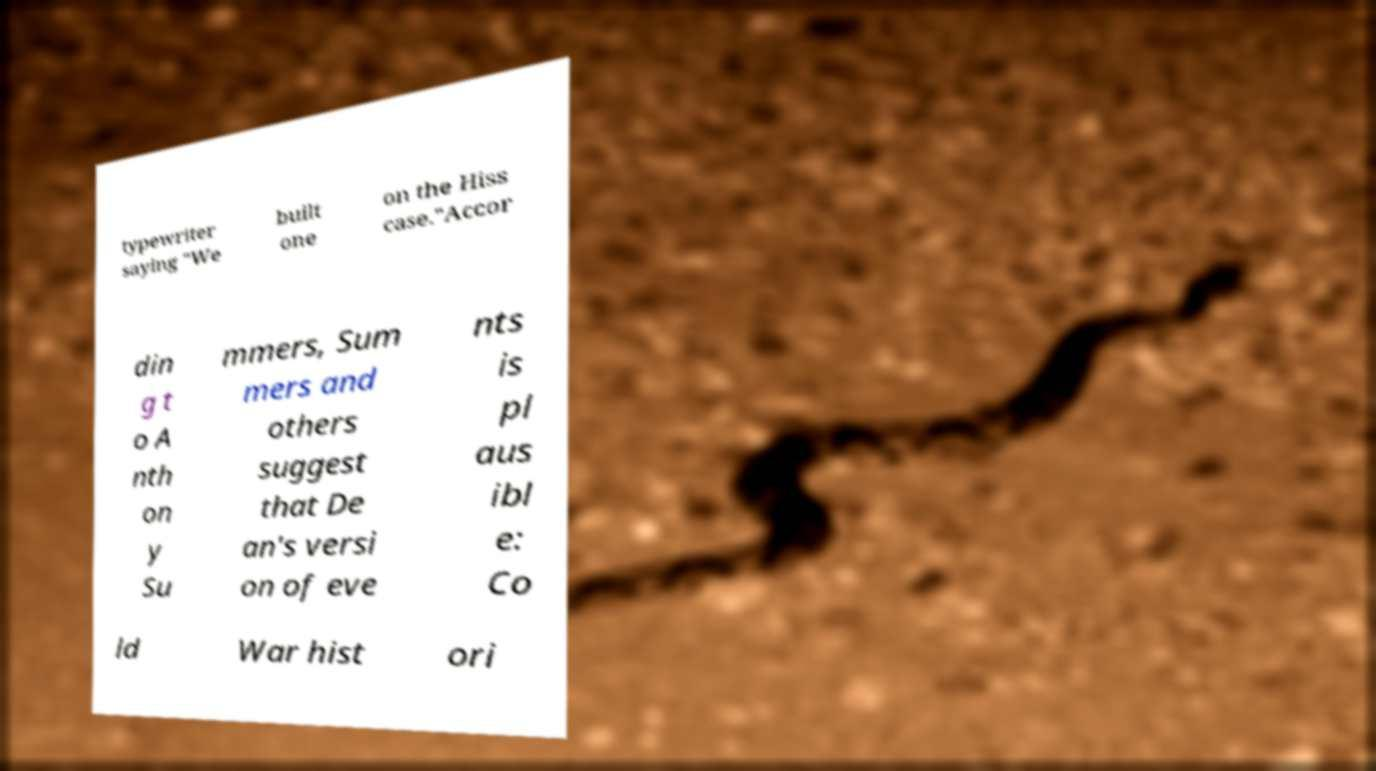Could you extract and type out the text from this image? typewriter saying "We built one on the Hiss case."Accor din g t o A nth on y Su mmers, Sum mers and others suggest that De an's versi on of eve nts is pl aus ibl e: Co ld War hist ori 